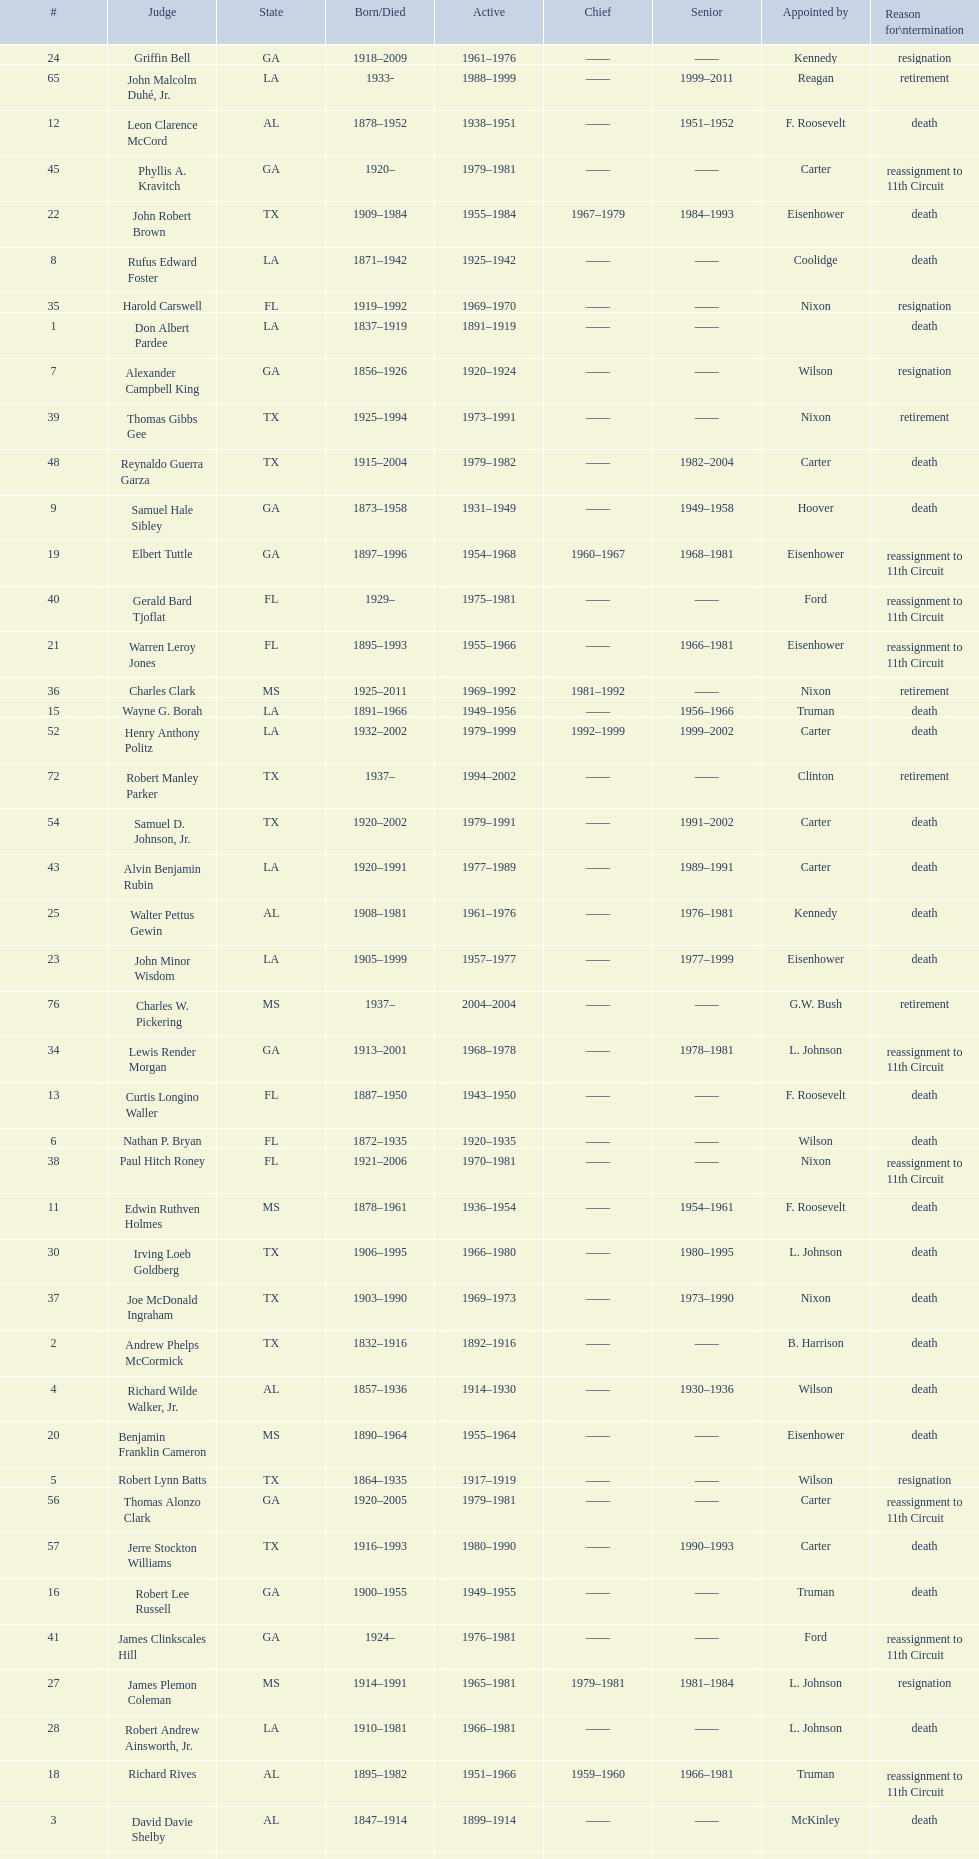Which judge was last appointed by president truman? Richard Rives. 